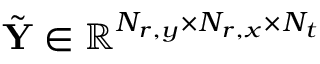<formula> <loc_0><loc_0><loc_500><loc_500>\tilde { Y } \in \mathbb { R } ^ { N _ { r , y } \times N _ { r , x } \times N _ { t } }</formula> 